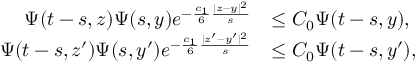<formula> <loc_0><loc_0><loc_500><loc_500>\begin{array} { r l } { \Psi ( t - s , z ) \Psi ( s , y ) e ^ { - \frac { c _ { 1 } } { 6 } \frac { | z - y | ^ { 2 } } { s } } } & { \leq C _ { 0 } \Psi ( t - s , y ) , } \\ { \Psi ( t - s , z ^ { \prime } ) \Psi ( s , y ^ { \prime } ) e ^ { - \frac { c _ { 1 } } { 6 } \frac { | z ^ { \prime } - y ^ { \prime } | ^ { 2 } } { s } } } & { \leq C _ { 0 } \Psi ( t - s , y ^ { \prime } ) , } \end{array}</formula> 